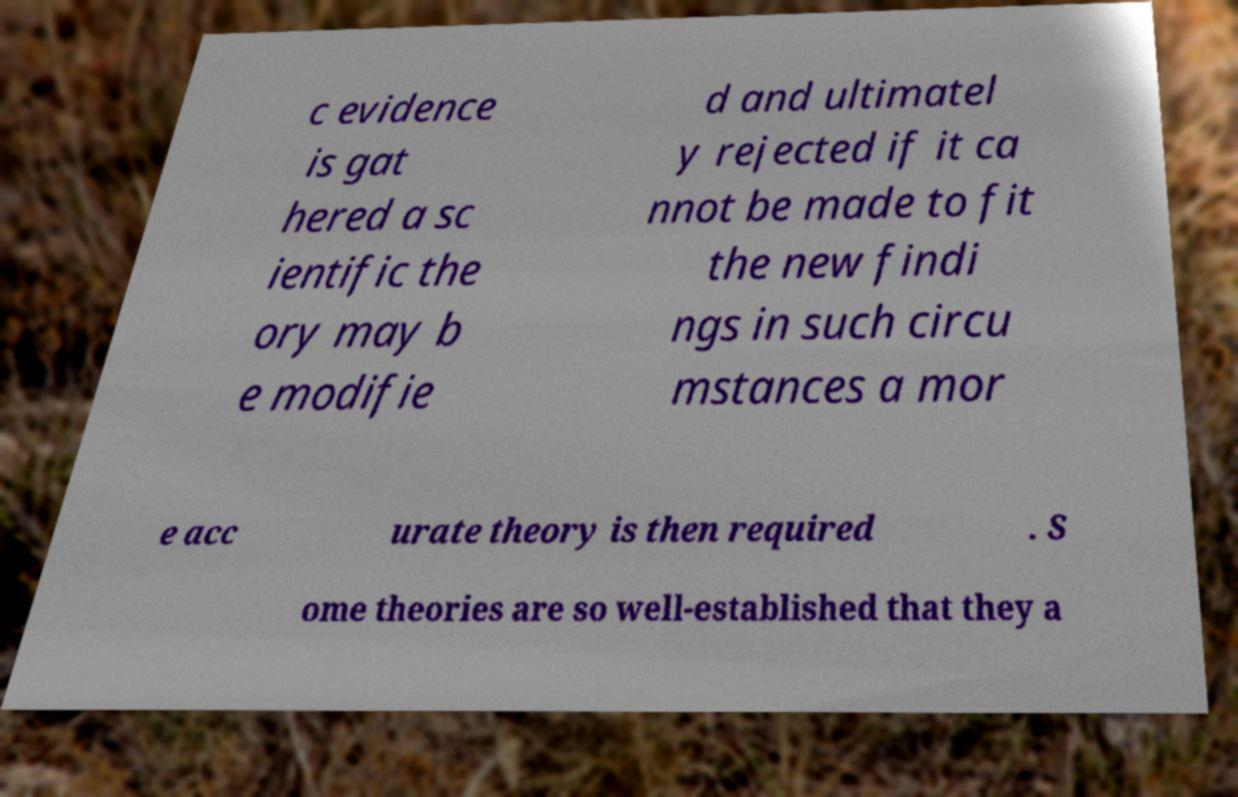Can you read and provide the text displayed in the image?This photo seems to have some interesting text. Can you extract and type it out for me? c evidence is gat hered a sc ientific the ory may b e modifie d and ultimatel y rejected if it ca nnot be made to fit the new findi ngs in such circu mstances a mor e acc urate theory is then required . S ome theories are so well-established that they a 